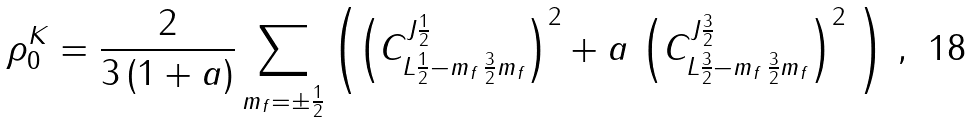Convert formula to latex. <formula><loc_0><loc_0><loc_500><loc_500>\rho ^ { K } _ { 0 } = \frac { 2 } { 3 \, ( 1 + a ) } \sum _ { m _ { f } = \pm \frac { 1 } { 2 } } \left ( \left ( C ^ { J \frac { 1 } { 2 } } _ { L \frac { 1 } { 2 } - m _ { f } \, \frac { 3 } { 2 } m _ { f } } \right ) ^ { 2 } + a \, \left ( C ^ { J \frac { 3 } { 2 } } _ { L \frac { 3 } { 2 } - m _ { f } \, \frac { 3 } { 2 } m _ { f } } \right ) ^ { 2 } \ \right ) \, ,</formula> 